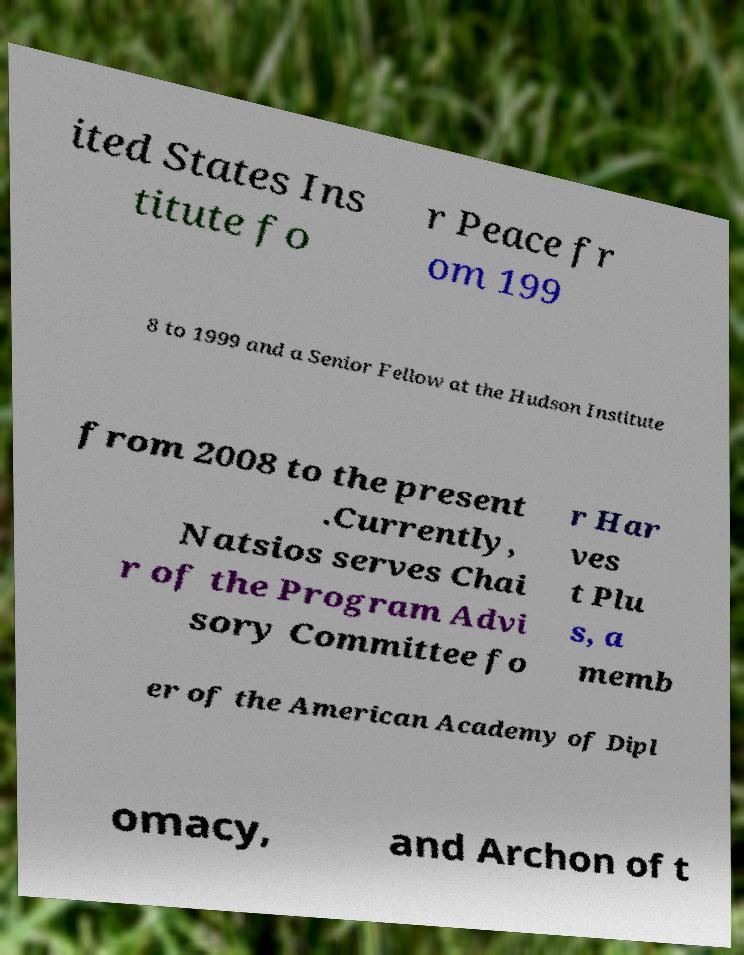For documentation purposes, I need the text within this image transcribed. Could you provide that? ited States Ins titute fo r Peace fr om 199 8 to 1999 and a Senior Fellow at the Hudson Institute from 2008 to the present .Currently, Natsios serves Chai r of the Program Advi sory Committee fo r Har ves t Plu s, a memb er of the American Academy of Dipl omacy, and Archon of t 